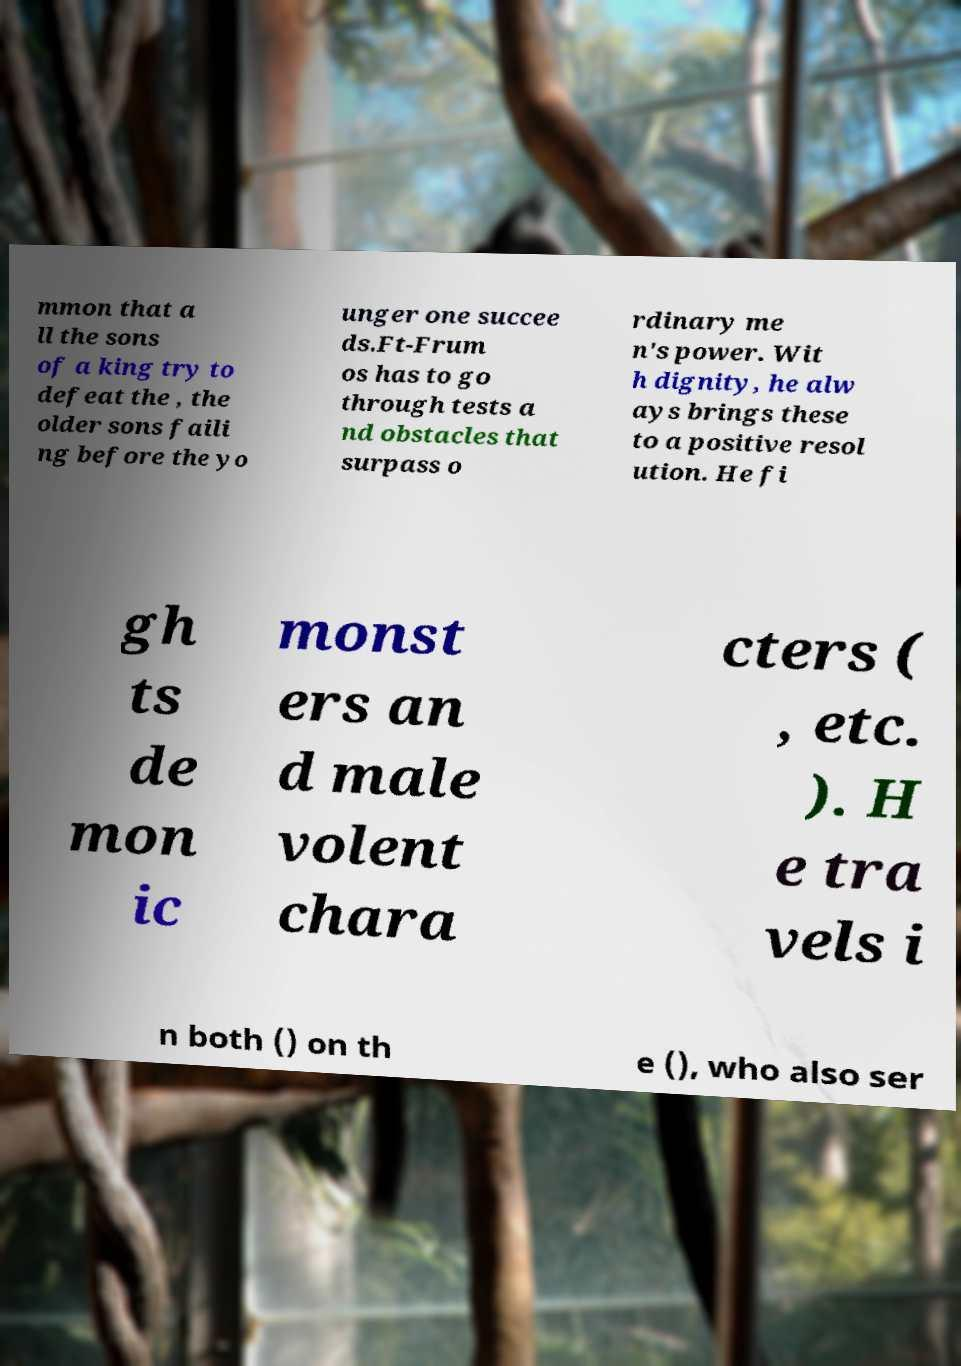Could you extract and type out the text from this image? mmon that a ll the sons of a king try to defeat the , the older sons faili ng before the yo unger one succee ds.Ft-Frum os has to go through tests a nd obstacles that surpass o rdinary me n's power. Wit h dignity, he alw ays brings these to a positive resol ution. He fi gh ts de mon ic monst ers an d male volent chara cters ( , etc. ). H e tra vels i n both () on th e (), who also ser 